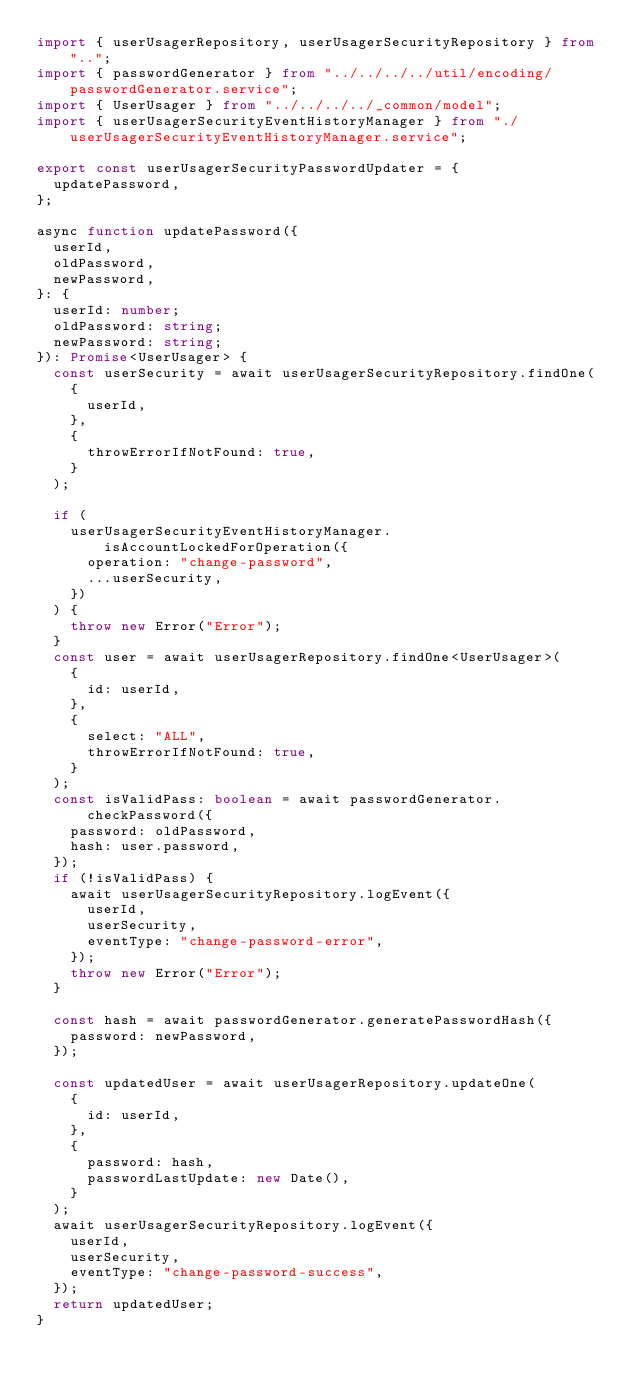<code> <loc_0><loc_0><loc_500><loc_500><_TypeScript_>import { userUsagerRepository, userUsagerSecurityRepository } from "..";
import { passwordGenerator } from "../../../../util/encoding/passwordGenerator.service";
import { UserUsager } from "../../../../_common/model";
import { userUsagerSecurityEventHistoryManager } from "./userUsagerSecurityEventHistoryManager.service";

export const userUsagerSecurityPasswordUpdater = {
  updatePassword,
};

async function updatePassword({
  userId,
  oldPassword,
  newPassword,
}: {
  userId: number;
  oldPassword: string;
  newPassword: string;
}): Promise<UserUsager> {
  const userSecurity = await userUsagerSecurityRepository.findOne(
    {
      userId,
    },
    {
      throwErrorIfNotFound: true,
    }
  );

  if (
    userUsagerSecurityEventHistoryManager.isAccountLockedForOperation({
      operation: "change-password",
      ...userSecurity,
    })
  ) {
    throw new Error("Error");
  }
  const user = await userUsagerRepository.findOne<UserUsager>(
    {
      id: userId,
    },
    {
      select: "ALL",
      throwErrorIfNotFound: true,
    }
  );
  const isValidPass: boolean = await passwordGenerator.checkPassword({
    password: oldPassword,
    hash: user.password,
  });
  if (!isValidPass) {
    await userUsagerSecurityRepository.logEvent({
      userId,
      userSecurity,
      eventType: "change-password-error",
    });
    throw new Error("Error");
  }

  const hash = await passwordGenerator.generatePasswordHash({
    password: newPassword,
  });

  const updatedUser = await userUsagerRepository.updateOne(
    {
      id: userId,
    },
    {
      password: hash,
      passwordLastUpdate: new Date(),
    }
  );
  await userUsagerSecurityRepository.logEvent({
    userId,
    userSecurity,
    eventType: "change-password-success",
  });
  return updatedUser;
}
</code> 